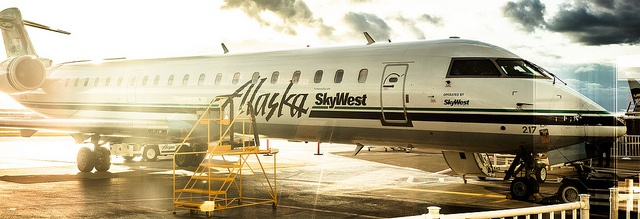Describe the objects in this image and their specific colors. I can see airplane in white, tan, beige, and black tones and truck in white, khaki, and tan tones in this image. 